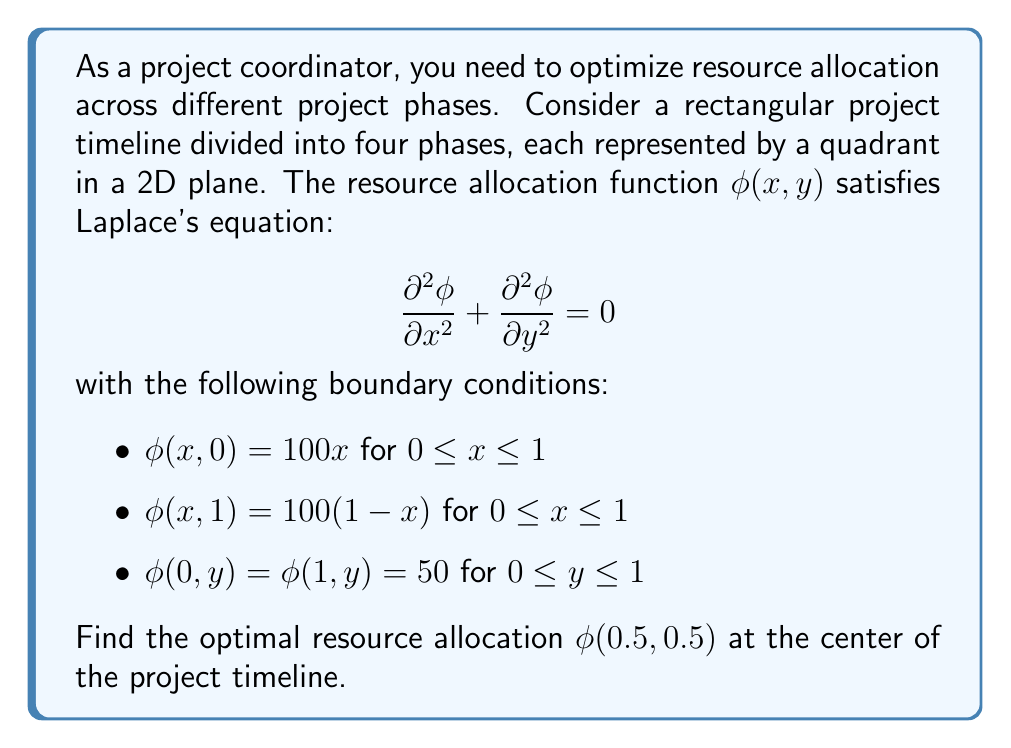Could you help me with this problem? To solve this problem, we'll use the method of separation of variables:

1) Assume $\phi(x,y) = X(x)Y(y)$

2) Substituting into Laplace's equation:
   $$Y\frac{d^2X}{dx^2} + X\frac{d^2Y}{dy^2} = 0$$

3) Dividing by $XY$:
   $$\frac{1}{X}\frac{d^2X}{dx^2} = -\frac{1}{Y}\frac{d^2Y}{dy^2} = \lambda^2$$

4) This gives us two ODEs:
   $$\frac{d^2X}{dx^2} - \lambda^2X = 0$$
   $$\frac{d^2Y}{dy^2} + \lambda^2Y = 0$$

5) The general solutions are:
   $$X(x) = A\cosh(\lambda x) + B\sinh(\lambda x)$$
   $$Y(y) = C\cos(\lambda y) + D\sin(\lambda y)$$

6) Applying the boundary conditions $\phi(0,y) = \phi(1,y) = 50$:
   $$A = 50, \quad A\cosh(\lambda) + B\sinh(\lambda) = 50$$

7) This implies $B = 0$ and $\cosh(\lambda) = 1$, giving $\lambda = 2n\pi$ for $n = 0, 1, 2, ...$

8) The solution can be written as:
   $$\phi(x,y) = 50 + \sum_{n=1}^{\infty} [a_n\cos(2n\pi y) + b_n\sin(2n\pi y)]\cosh(2n\pi x)$$

9) To satisfy the remaining boundary conditions, we need:
   $$\sum_{n=1}^{\infty} a_n\cosh(2n\pi x) = 100x - 50 \quad \text{for } y = 0$$
   $$\sum_{n=1}^{\infty} [a_n\cos(2n\pi) + b_n\sin(2n\pi)]\cosh(2n\pi x) = 50 - 100x \quad \text{for } y = 1$$

10) This implies $b_n = 0$ for all $n$, and:
    $$a_n = \frac{400}{n\pi}\frac{(-1)^{n+1}}{2n\pi\cosh(n\pi)}$$

11) The final solution is:
    $$\phi(x,y) = 50 + \sum_{n=1}^{\infty} \frac{400}{n\pi}\frac{(-1)^{n+1}}{2n\pi\cosh(n\pi)}\cos(2n\pi y)\cosh(2n\pi x)$$

12) At the center point (0.5, 0.5):
    $$\phi(0.5,0.5) = 50 + \sum_{n=1}^{\infty} \frac{400}{n\pi}\frac{(-1)^{n+1}}{2n\pi\cosh(n\pi)}\cos(n\pi)\cosh(n\pi)$$

13) Simplifying:
    $$\phi(0.5,0.5) = 50 + \sum_{n=1}^{\infty} \frac{400}{(n\pi)^2}(-1)^{n+1}$$

14) This series can be evaluated to:
    $$\phi(0.5,0.5) = 50 + \frac{400}{\pi^2}(\frac{\pi^2}{8}) = 75$$
Answer: The optimal resource allocation at the center of the project timeline is $\phi(0.5,0.5) = 75$. 